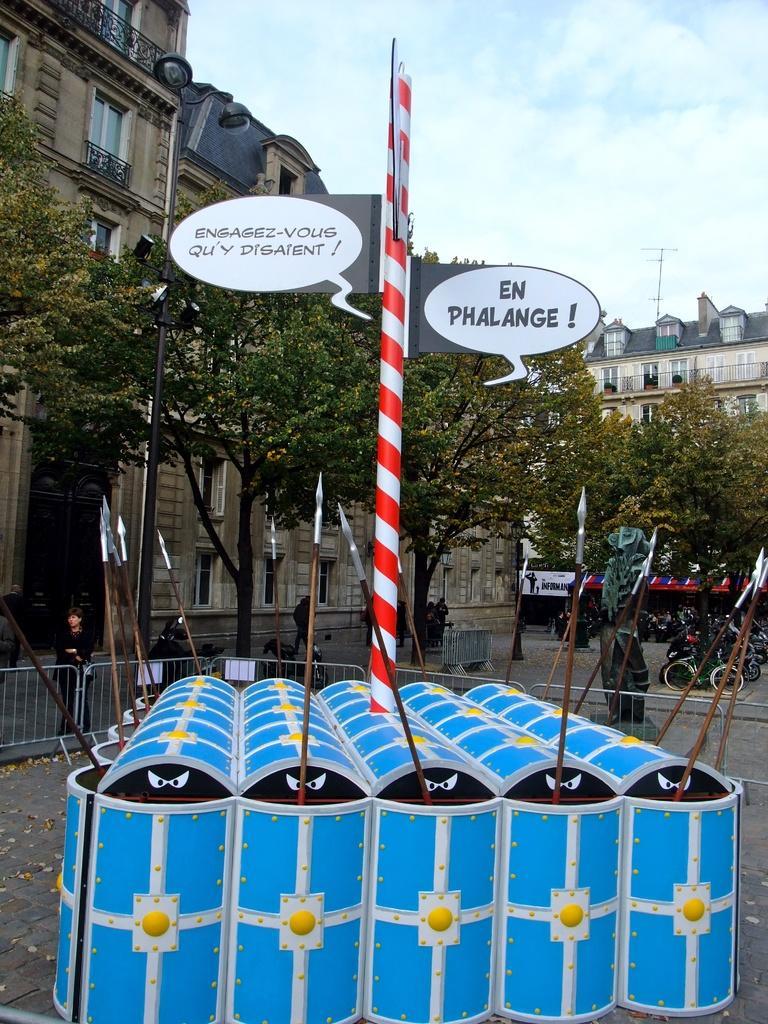Describe this image in one or two sentences. Here in this picture we can see a pole present on a place that is covered with iron sheets and beside that we can see some boards present and we can see trees also present over there and in the far we can see bicycles present and we can also see statue present and we can see buildings present over there and on the left side we can see a railing present over there and we can see clouds in the sky over there. 